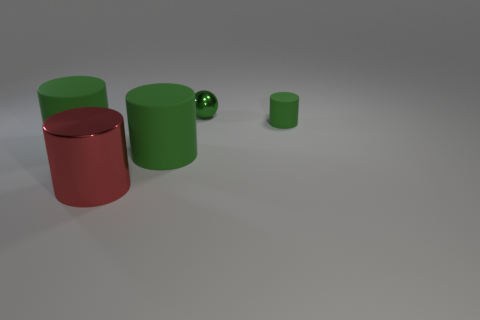Are the red thing and the small green cylinder made of the same material?
Keep it short and to the point. No. There is a red cylinder that is in front of the small green object to the left of the green cylinder to the right of the green sphere; what is it made of?
Make the answer very short. Metal. Is there any other thing that is the same color as the metallic cylinder?
Offer a very short reply. No. There is a cylinder that is to the right of the big red metal object and to the left of the small green matte cylinder; what material is it made of?
Provide a succinct answer. Rubber. What number of red objects have the same size as the green metallic thing?
Your answer should be very brief. 0. What number of rubber things are small things or big green things?
Offer a very short reply. 3. What is the red cylinder made of?
Give a very brief answer. Metal. What number of green matte cylinders are behind the tiny green shiny thing?
Offer a very short reply. 0. Is the material of the small thing behind the tiny green cylinder the same as the big red object?
Ensure brevity in your answer.  Yes. What number of small rubber objects are the same shape as the big red thing?
Keep it short and to the point. 1. 